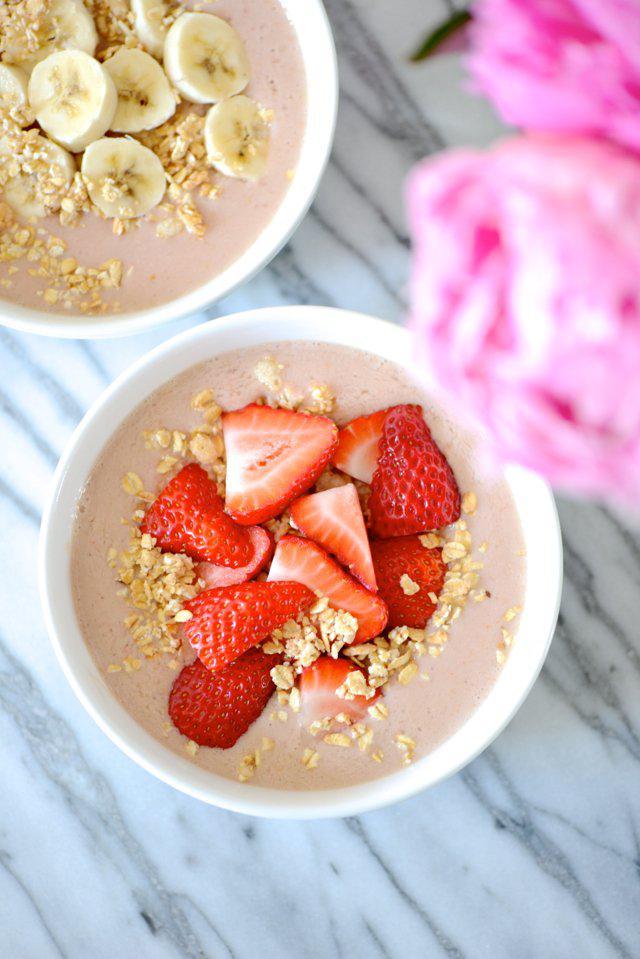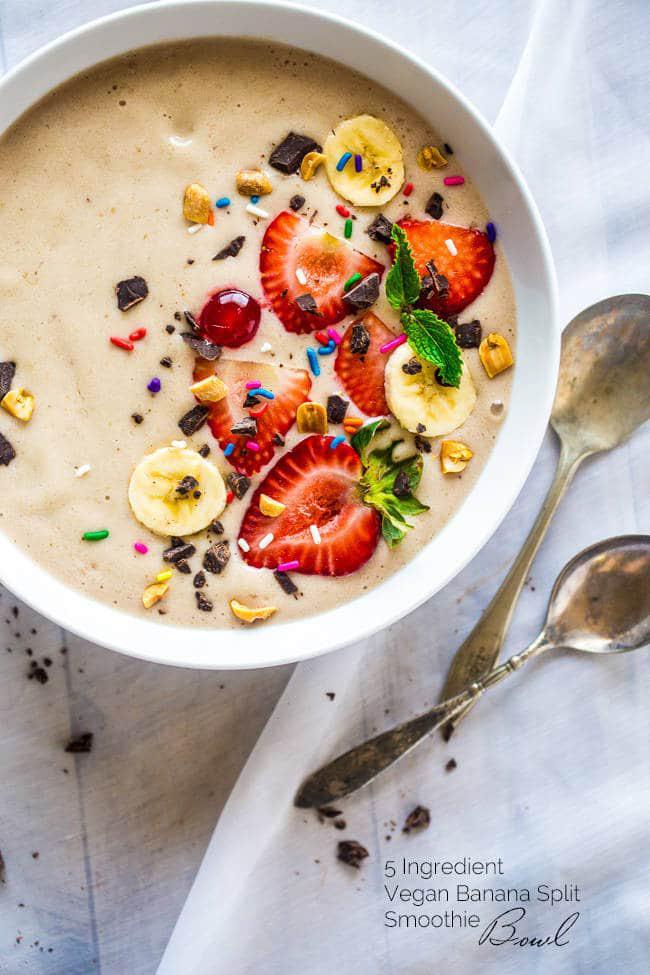The first image is the image on the left, the second image is the image on the right. Considering the images on both sides, is "There are at least two white bowls." valid? Answer yes or no. Yes. The first image is the image on the left, the second image is the image on the right. Evaluate the accuracy of this statement regarding the images: "The combined images include a white bowl topped with blueberries and other ingredients, a square white container of fruit behind a white bowl, and a blue-striped white cloth next to a bowl.". Is it true? Answer yes or no. No. 